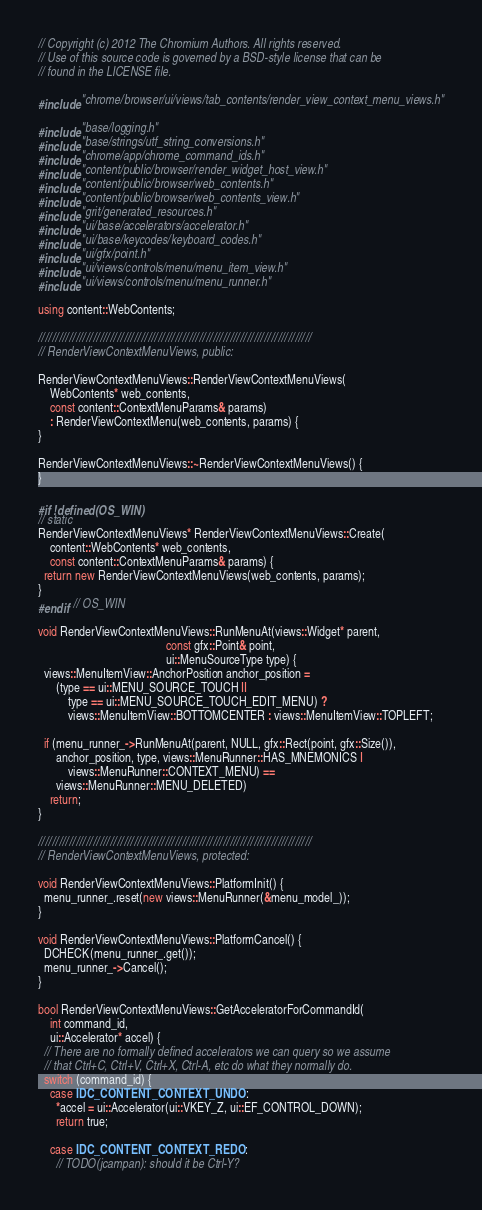<code> <loc_0><loc_0><loc_500><loc_500><_C++_>// Copyright (c) 2012 The Chromium Authors. All rights reserved.
// Use of this source code is governed by a BSD-style license that can be
// found in the LICENSE file.

#include "chrome/browser/ui/views/tab_contents/render_view_context_menu_views.h"

#include "base/logging.h"
#include "base/strings/utf_string_conversions.h"
#include "chrome/app/chrome_command_ids.h"
#include "content/public/browser/render_widget_host_view.h"
#include "content/public/browser/web_contents.h"
#include "content/public/browser/web_contents_view.h"
#include "grit/generated_resources.h"
#include "ui/base/accelerators/accelerator.h"
#include "ui/base/keycodes/keyboard_codes.h"
#include "ui/gfx/point.h"
#include "ui/views/controls/menu/menu_item_view.h"
#include "ui/views/controls/menu/menu_runner.h"

using content::WebContents;

////////////////////////////////////////////////////////////////////////////////
// RenderViewContextMenuViews, public:

RenderViewContextMenuViews::RenderViewContextMenuViews(
    WebContents* web_contents,
    const content::ContextMenuParams& params)
    : RenderViewContextMenu(web_contents, params) {
}

RenderViewContextMenuViews::~RenderViewContextMenuViews() {
}

#if !defined(OS_WIN)
// static
RenderViewContextMenuViews* RenderViewContextMenuViews::Create(
    content::WebContents* web_contents,
    const content::ContextMenuParams& params) {
  return new RenderViewContextMenuViews(web_contents, params);
}
#endif  // OS_WIN

void RenderViewContextMenuViews::RunMenuAt(views::Widget* parent,
                                           const gfx::Point& point,
                                           ui::MenuSourceType type) {
  views::MenuItemView::AnchorPosition anchor_position =
      (type == ui::MENU_SOURCE_TOUCH ||
          type == ui::MENU_SOURCE_TOUCH_EDIT_MENU) ?
          views::MenuItemView::BOTTOMCENTER : views::MenuItemView::TOPLEFT;

  if (menu_runner_->RunMenuAt(parent, NULL, gfx::Rect(point, gfx::Size()),
      anchor_position, type, views::MenuRunner::HAS_MNEMONICS |
          views::MenuRunner::CONTEXT_MENU) ==
      views::MenuRunner::MENU_DELETED)
    return;
}

////////////////////////////////////////////////////////////////////////////////
// RenderViewContextMenuViews, protected:

void RenderViewContextMenuViews::PlatformInit() {
  menu_runner_.reset(new views::MenuRunner(&menu_model_));
}

void RenderViewContextMenuViews::PlatformCancel() {
  DCHECK(menu_runner_.get());
  menu_runner_->Cancel();
}

bool RenderViewContextMenuViews::GetAcceleratorForCommandId(
    int command_id,
    ui::Accelerator* accel) {
  // There are no formally defined accelerators we can query so we assume
  // that Ctrl+C, Ctrl+V, Ctrl+X, Ctrl-A, etc do what they normally do.
  switch (command_id) {
    case IDC_CONTENT_CONTEXT_UNDO:
      *accel = ui::Accelerator(ui::VKEY_Z, ui::EF_CONTROL_DOWN);
      return true;

    case IDC_CONTENT_CONTEXT_REDO:
      // TODO(jcampan): should it be Ctrl-Y?</code> 